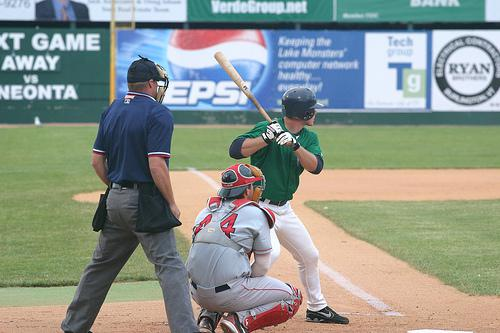Question: what sport is being played?
Choices:
A. Tennis.
B. Basketball.
C. Football.
D. Baseball.
Answer with the letter. Answer: D Question: what brand of soda is being advertised?
Choices:
A. Coca Cola.
B. Pepsi.
C. Sprite.
D. Dr Pepper.
Answer with the letter. Answer: B Question: where does the white line lead?
Choices:
A. To the left.
B. Third base.
C. To the building.
D. To the edge of the parking lot.
Answer with the letter. Answer: B Question: where does the catcher sit?
Choices:
A. Behind home plate.
B. On the baseball field.
C. On the grass.
D. On the red ground.
Answer with the letter. Answer: A 